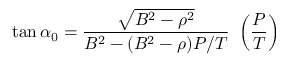Convert formula to latex. <formula><loc_0><loc_0><loc_500><loc_500>\tan \alpha _ { 0 } = \frac { \sqrt { B ^ { 2 } - \rho ^ { 2 } } } { B ^ { 2 } - ( B ^ { 2 } - \rho ) P / T } \ \left ( \frac { P } { T } \right )</formula> 